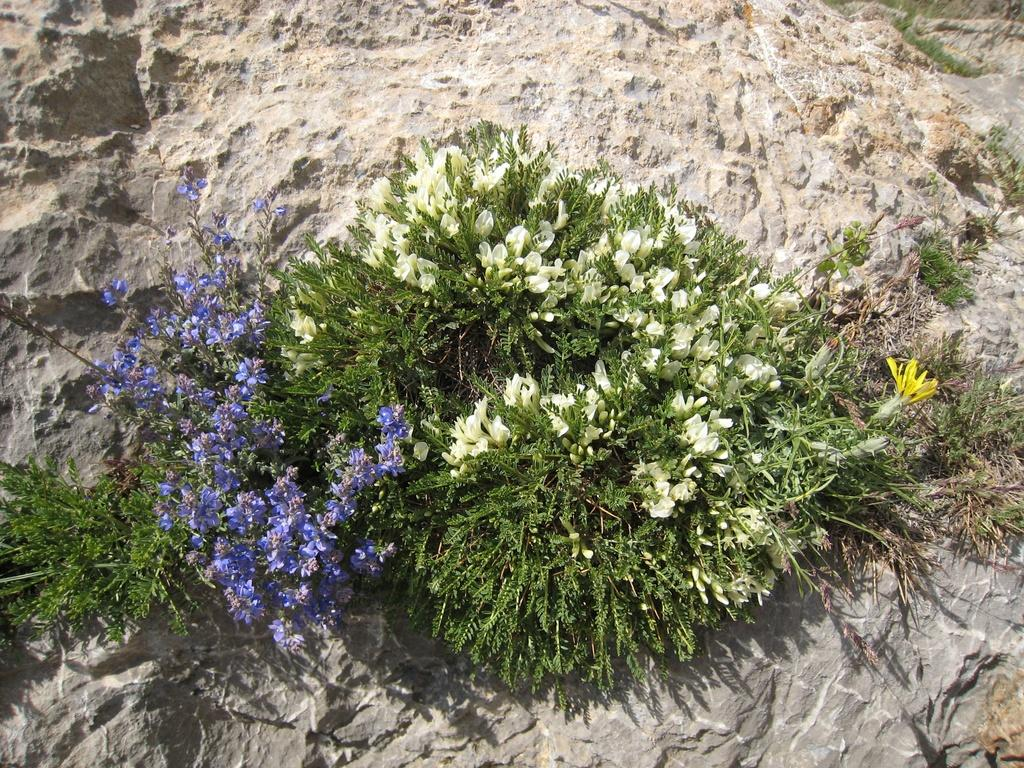What type of plants can be seen in the image? There are flower plants in the image. Can you describe any other elements in the background of the image? There is a rock in the background of the image. What is the health status of the person sneezing in the image? There is no person sneezing in the image; it only features flower plants and a rock. 